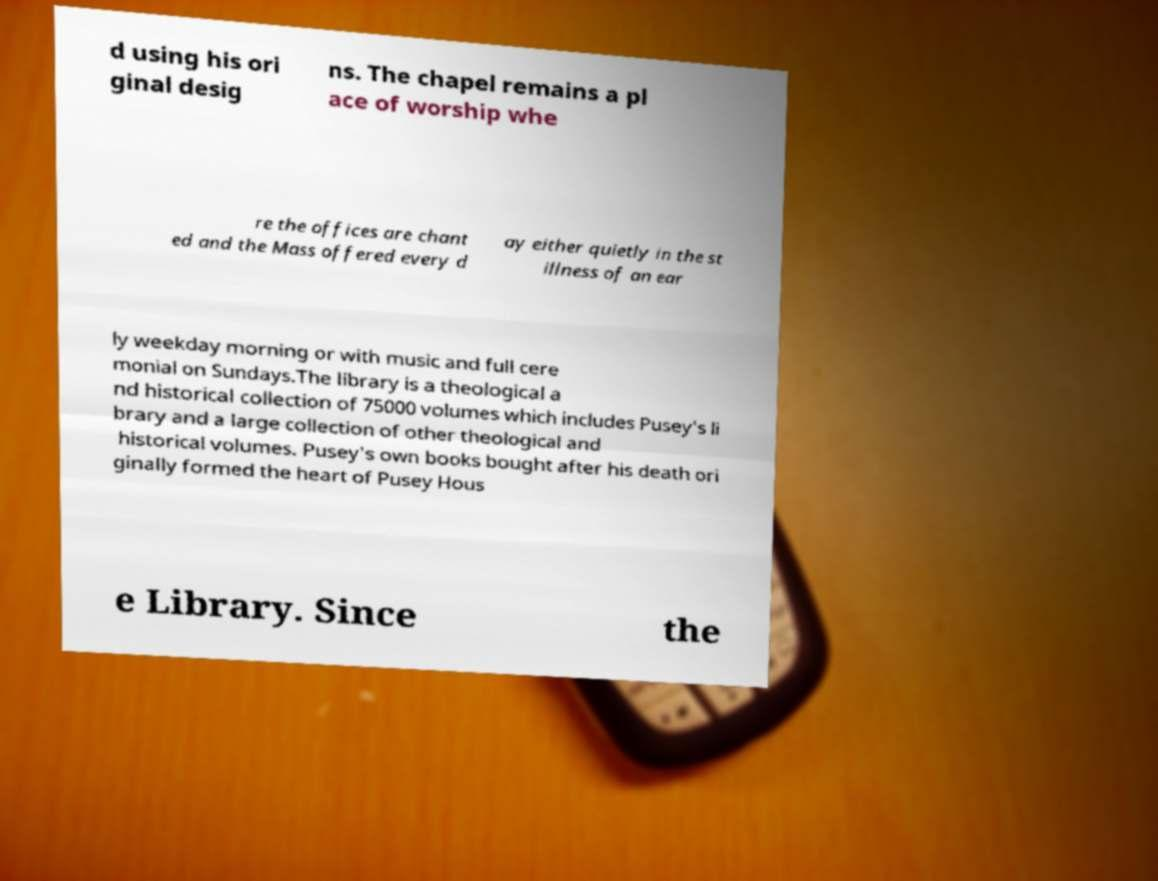Can you accurately transcribe the text from the provided image for me? d using his ori ginal desig ns. The chapel remains a pl ace of worship whe re the offices are chant ed and the Mass offered every d ay either quietly in the st illness of an ear ly weekday morning or with music and full cere monial on Sundays.The library is a theological a nd historical collection of 75000 volumes which includes Pusey's li brary and a large collection of other theological and historical volumes. Pusey's own books bought after his death ori ginally formed the heart of Pusey Hous e Library. Since the 